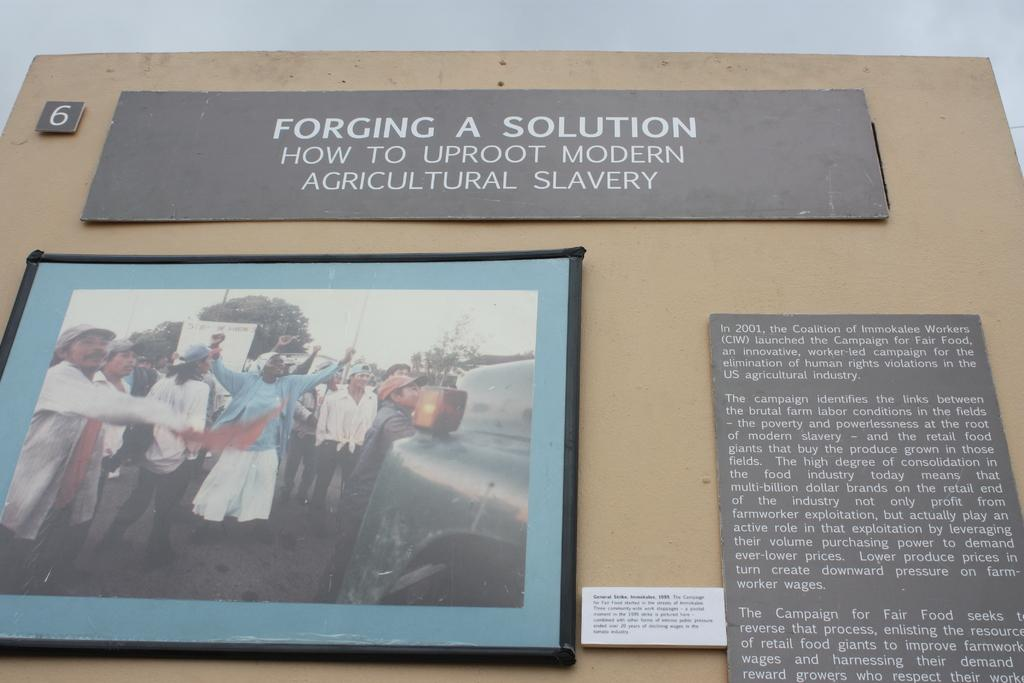<image>
Present a compact description of the photo's key features. a number 6 in the top left corner of an image 